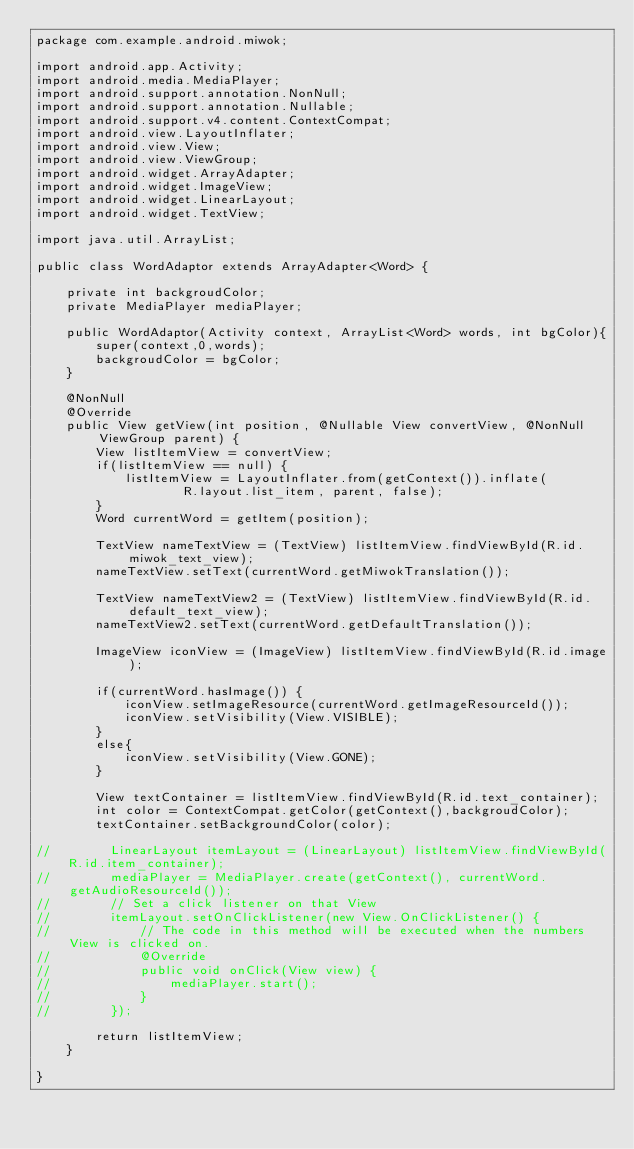<code> <loc_0><loc_0><loc_500><loc_500><_Java_>package com.example.android.miwok;

import android.app.Activity;
import android.media.MediaPlayer;
import android.support.annotation.NonNull;
import android.support.annotation.Nullable;
import android.support.v4.content.ContextCompat;
import android.view.LayoutInflater;
import android.view.View;
import android.view.ViewGroup;
import android.widget.ArrayAdapter;
import android.widget.ImageView;
import android.widget.LinearLayout;
import android.widget.TextView;

import java.util.ArrayList;

public class WordAdaptor extends ArrayAdapter<Word> {

    private int backgroudColor;
    private MediaPlayer mediaPlayer;

    public WordAdaptor(Activity context, ArrayList<Word> words, int bgColor){
        super(context,0,words);
        backgroudColor = bgColor;
    }

    @NonNull
    @Override
    public View getView(int position, @Nullable View convertView, @NonNull ViewGroup parent) {
        View listItemView = convertView;
        if(listItemView == null) {
            listItemView = LayoutInflater.from(getContext()).inflate(
                    R.layout.list_item, parent, false);
        }
        Word currentWord = getItem(position);

        TextView nameTextView = (TextView) listItemView.findViewById(R.id.miwok_text_view);
        nameTextView.setText(currentWord.getMiwokTranslation());

        TextView nameTextView2 = (TextView) listItemView.findViewById(R.id.default_text_view);
        nameTextView2.setText(currentWord.getDefaultTranslation());

        ImageView iconView = (ImageView) listItemView.findViewById(R.id.image);

        if(currentWord.hasImage()) {
            iconView.setImageResource(currentWord.getImageResourceId());
            iconView.setVisibility(View.VISIBLE);
        }
        else{
            iconView.setVisibility(View.GONE);
        }

        View textContainer = listItemView.findViewById(R.id.text_container);
        int color = ContextCompat.getColor(getContext(),backgroudColor);
        textContainer.setBackgroundColor(color);

//        LinearLayout itemLayout = (LinearLayout) listItemView.findViewById(R.id.item_container);
//        mediaPlayer = MediaPlayer.create(getContext(), currentWord.getAudioResourceId());
//        // Set a click listener on that View
//        itemLayout.setOnClickListener(new View.OnClickListener() {
//            // The code in this method will be executed when the numbers View is clicked on.
//            @Override
//            public void onClick(View view) {
//                mediaPlayer.start();
//            }
//        });

        return listItemView;
    }

}
</code> 